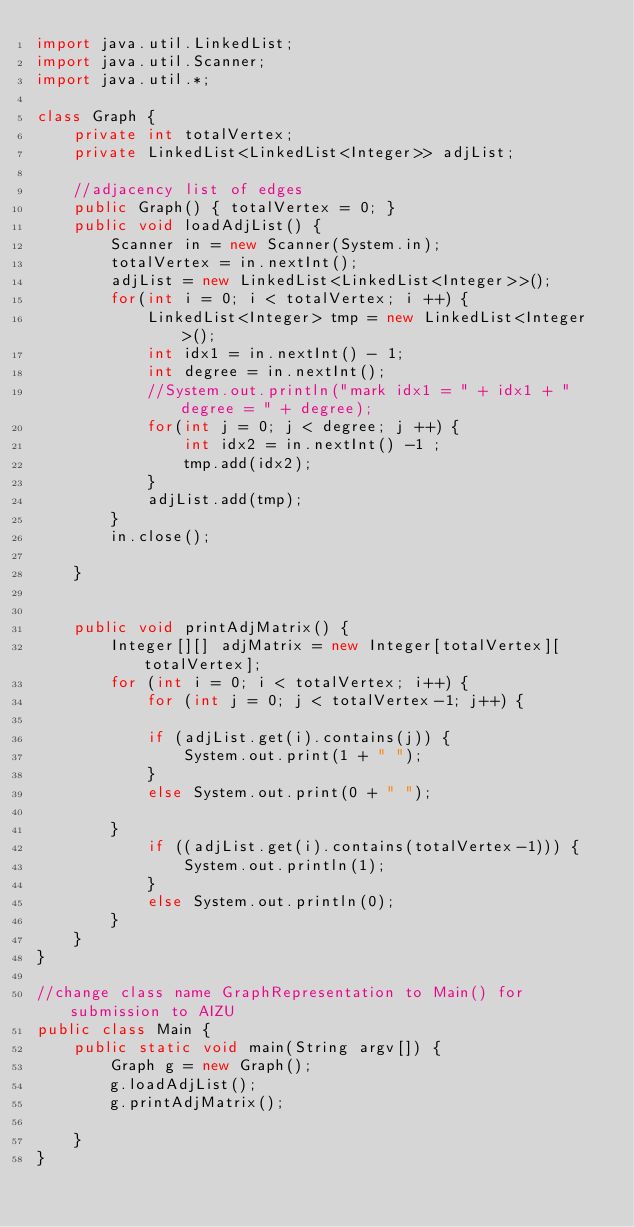Convert code to text. <code><loc_0><loc_0><loc_500><loc_500><_Java_>import java.util.LinkedList;
import java.util.Scanner;
import java.util.*;

class Graph {
	private int totalVertex;
	private LinkedList<LinkedList<Integer>> adjList;
	
	//adjacency list of edges
	public Graph() { totalVertex = 0; }
	public void loadAdjList() {
		Scanner in = new Scanner(System.in);
		totalVertex = in.nextInt();
		adjList = new LinkedList<LinkedList<Integer>>();
		for(int i = 0; i < totalVertex; i ++) {
			LinkedList<Integer> tmp = new LinkedList<Integer>();
			int idx1 = in.nextInt() - 1;
			int degree = in.nextInt();
			//System.out.println("mark idx1 = " + idx1 + " degree = " + degree);
			for(int j = 0; j < degree; j ++) {
				int idx2 = in.nextInt() -1 ;
				tmp.add(idx2);
			}	
			adjList.add(tmp);
		}
		in.close();

	}
	

	public void printAdjMatrix() {
		Integer[][] adjMatrix = new Integer[totalVertex][totalVertex];
		for (int i = 0; i < totalVertex; i++) {
			for (int j = 0; j < totalVertex-1; j++) {
				
			if (adjList.get(i).contains(j)) {
				System.out.print(1 + " ");
			}
			else System.out.print(0 + " ");
			
		}
			if ((adjList.get(i).contains(totalVertex-1))) {
				System.out.println(1);
			}
			else System.out.println(0);
		}
	}
}

//change class name GraphRepresentation to Main() for submission to AIZU
public class Main {
	public static void main(String argv[]) {
		Graph g = new Graph();
		g.loadAdjList();
		g.printAdjMatrix();
		
	}
}
</code> 